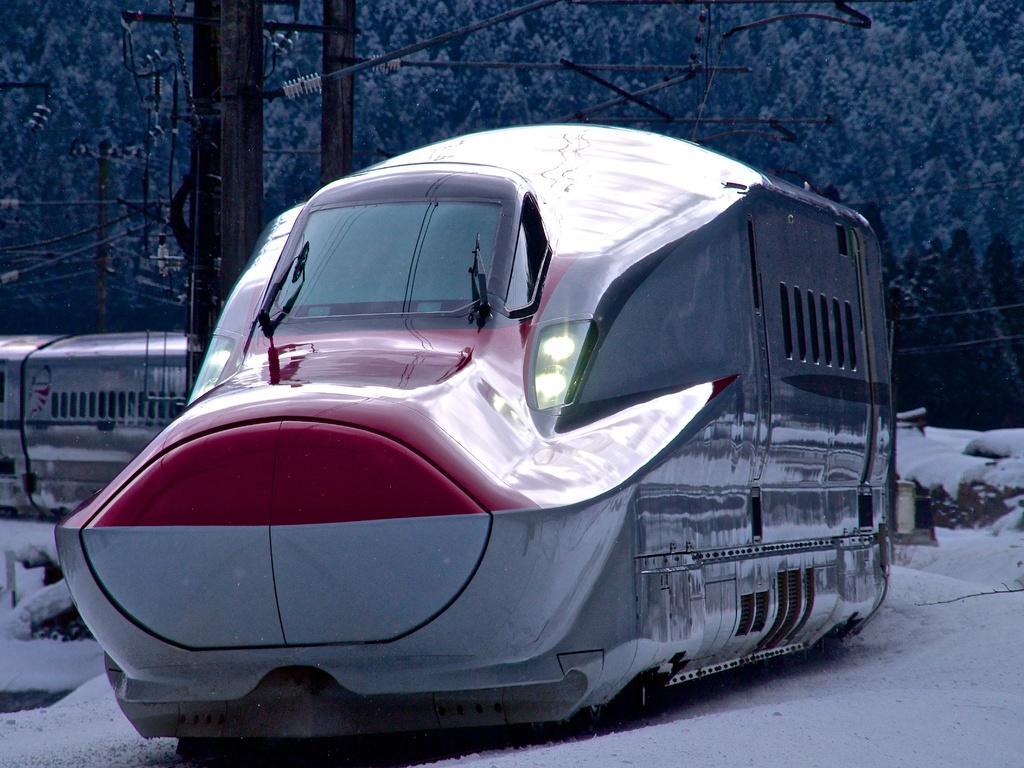Could you give a brief overview of what you see in this image? In the center of the image we can see a train. In the background of the image we can see the poles, wires, snow and trees. 